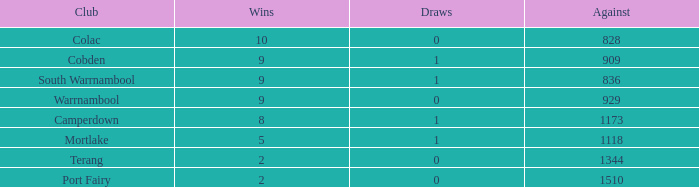What is the sum of against values for clubs that have over 2 victories, 5 defeats, and no ties? 0.0. 